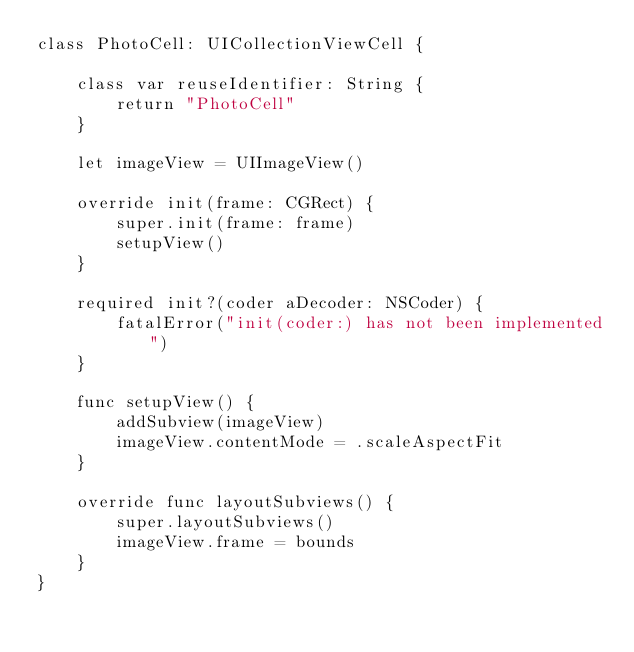<code> <loc_0><loc_0><loc_500><loc_500><_Swift_>class PhotoCell: UICollectionViewCell {
    
    class var reuseIdentifier: String {
        return "PhotoCell"
    }
    
    let imageView = UIImageView()
    
    override init(frame: CGRect) {
        super.init(frame: frame)
        setupView()
    }
    
    required init?(coder aDecoder: NSCoder) {
        fatalError("init(coder:) has not been implemented")
    }
    
    func setupView() {
        addSubview(imageView)
        imageView.contentMode = .scaleAspectFit
    }
    
    override func layoutSubviews() {
        super.layoutSubviews()
        imageView.frame = bounds
    }
}
</code> 